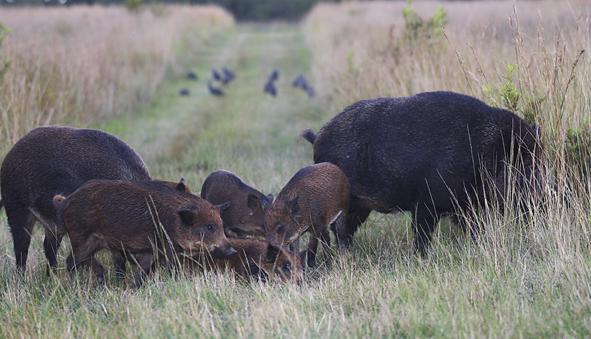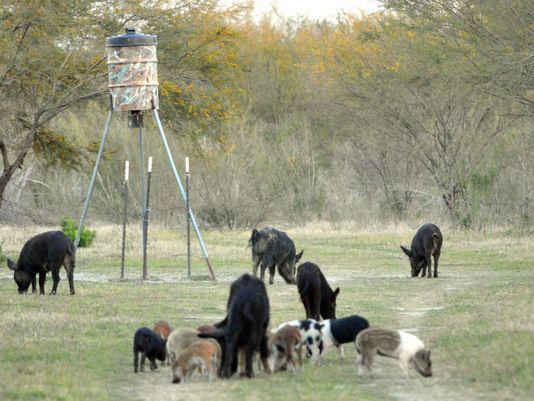The first image is the image on the left, the second image is the image on the right. Analyze the images presented: Is the assertion "A group of hogs is garthered near a barrel-shaped feeder on a tripod." valid? Answer yes or no. Yes. The first image is the image on the left, the second image is the image on the right. Evaluate the accuracy of this statement regarding the images: "There is a man made object in a field in one of the images.". Is it true? Answer yes or no. Yes. 